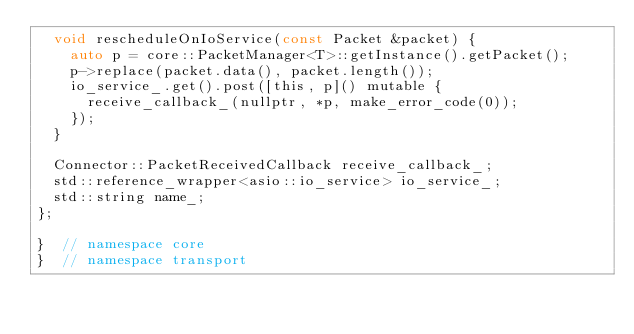Convert code to text. <code><loc_0><loc_0><loc_500><loc_500><_C_>  void rescheduleOnIoService(const Packet &packet) {
    auto p = core::PacketManager<T>::getInstance().getPacket();
    p->replace(packet.data(), packet.length());
    io_service_.get().post([this, p]() mutable {
      receive_callback_(nullptr, *p, make_error_code(0));
    });
  }

  Connector::PacketReceivedCallback receive_callback_;
  std::reference_wrapper<asio::io_service> io_service_;
  std::string name_;
};

}  // namespace core
}  // namespace transport
</code> 